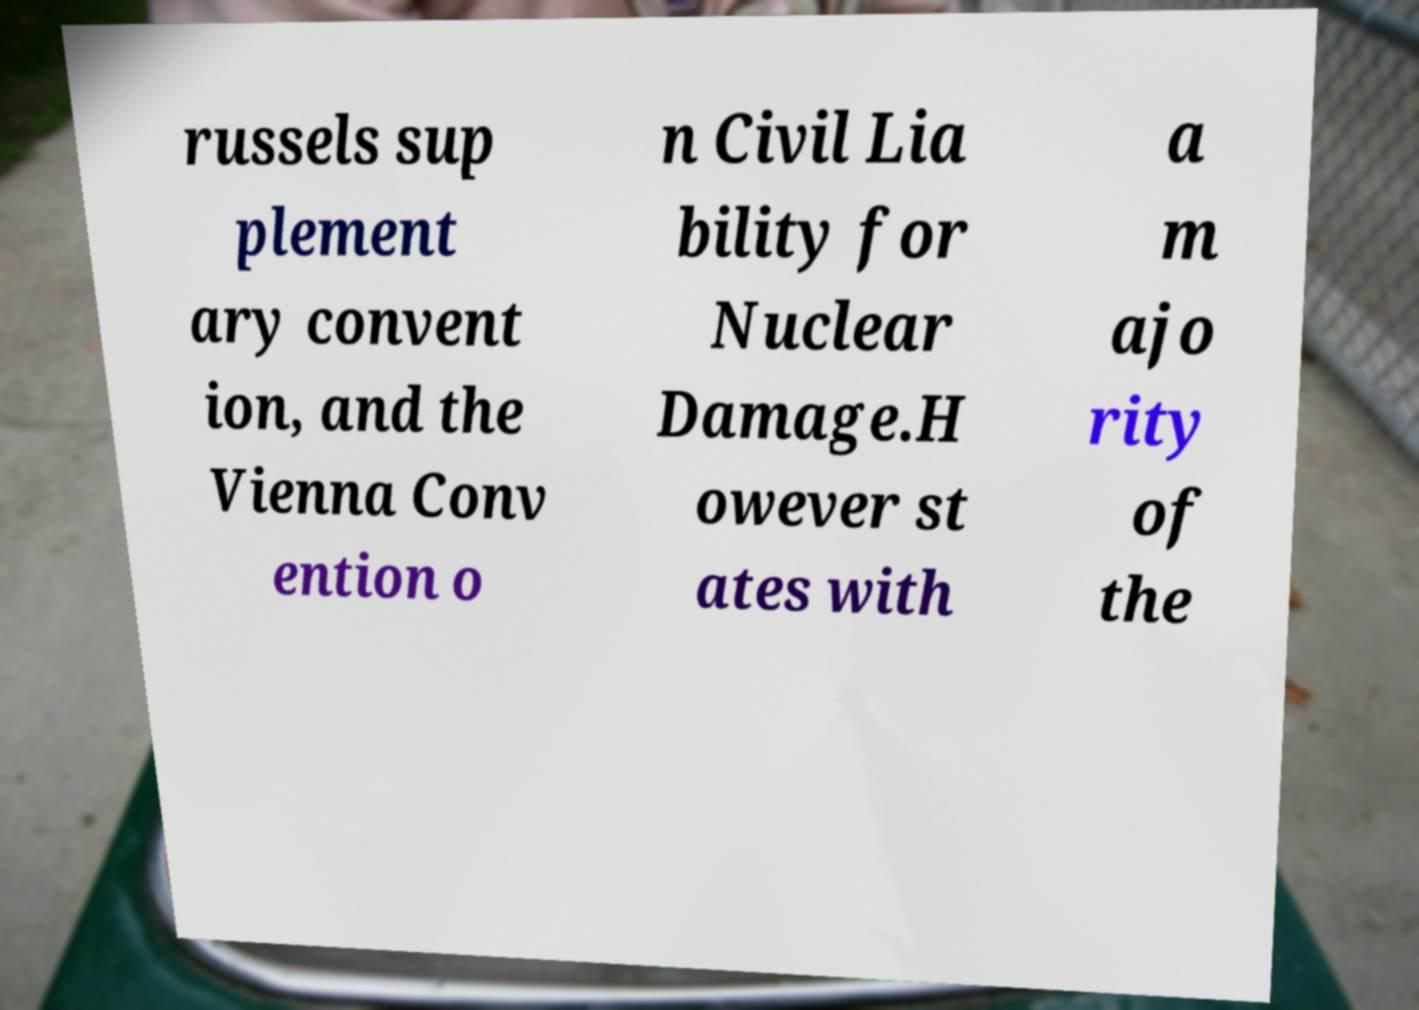What messages or text are displayed in this image? I need them in a readable, typed format. russels sup plement ary convent ion, and the Vienna Conv ention o n Civil Lia bility for Nuclear Damage.H owever st ates with a m ajo rity of the 